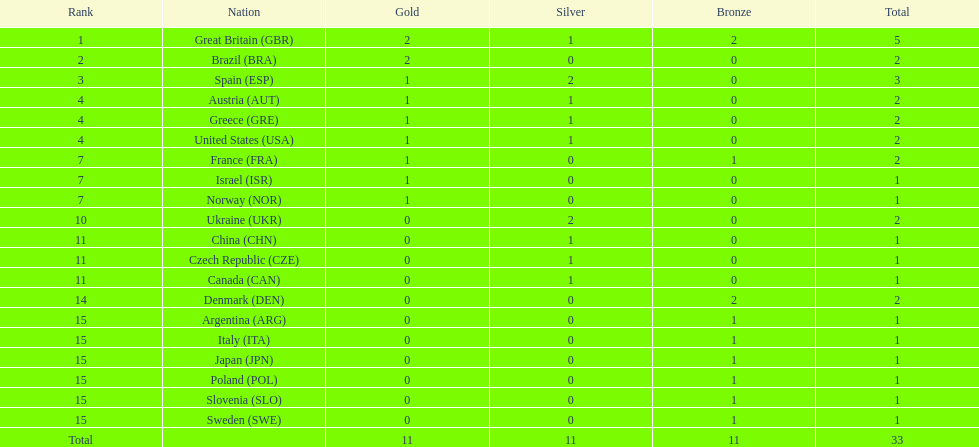What is the count of countries that have achieved at least one gold and one silver medal? 5. 